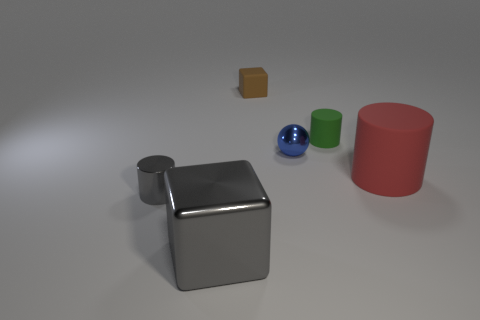Subtract 1 spheres. How many spheres are left? 0 Add 3 spheres. How many objects exist? 9 Subtract all gray cylinders. How many cylinders are left? 2 Subtract all tiny shiny cylinders. How many cylinders are left? 2 Subtract 1 green cylinders. How many objects are left? 5 Subtract all cubes. How many objects are left? 4 Subtract all blue cubes. Subtract all cyan cylinders. How many cubes are left? 2 Subtract all blue blocks. How many blue cylinders are left? 0 Subtract all tiny brown matte things. Subtract all balls. How many objects are left? 4 Add 1 red matte objects. How many red matte objects are left? 2 